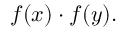Convert formula to latex. <formula><loc_0><loc_0><loc_500><loc_500>f ( x ) \cdot f ( y ) .</formula> 